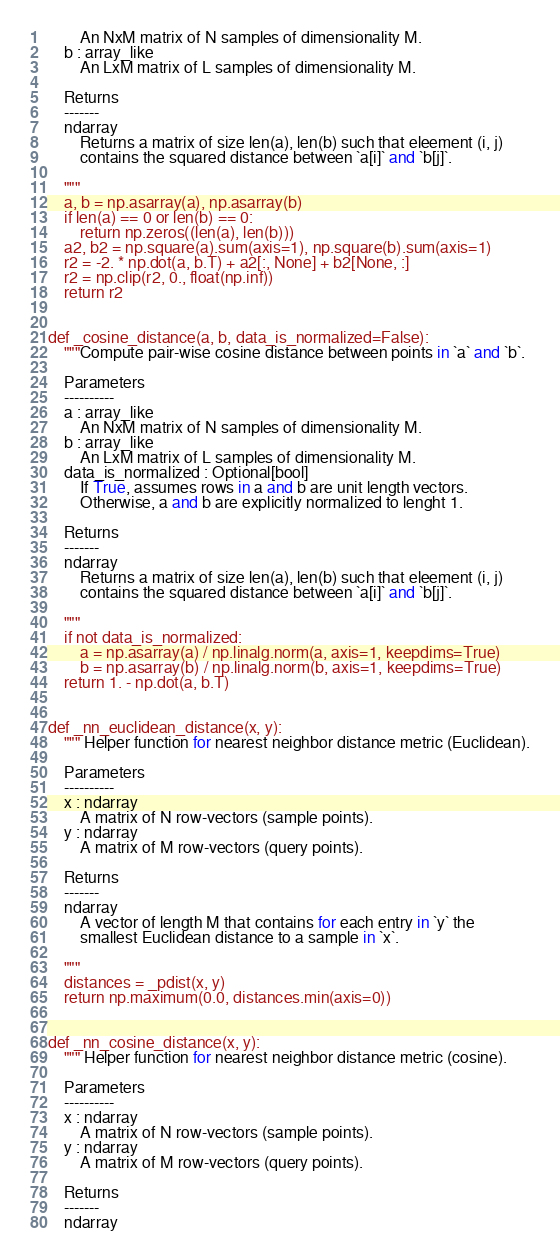<code> <loc_0><loc_0><loc_500><loc_500><_Python_>        An NxM matrix of N samples of dimensionality M.
    b : array_like
        An LxM matrix of L samples of dimensionality M.

    Returns
    -------
    ndarray
        Returns a matrix of size len(a), len(b) such that eleement (i, j)
        contains the squared distance between `a[i]` and `b[j]`.

    """
    a, b = np.asarray(a), np.asarray(b)
    if len(a) == 0 or len(b) == 0:
        return np.zeros((len(a), len(b)))
    a2, b2 = np.square(a).sum(axis=1), np.square(b).sum(axis=1)
    r2 = -2. * np.dot(a, b.T) + a2[:, None] + b2[None, :]
    r2 = np.clip(r2, 0., float(np.inf))
    return r2


def _cosine_distance(a, b, data_is_normalized=False):
    """Compute pair-wise cosine distance between points in `a` and `b`.

    Parameters
    ----------
    a : array_like
        An NxM matrix of N samples of dimensionality M.
    b : array_like
        An LxM matrix of L samples of dimensionality M.
    data_is_normalized : Optional[bool]
        If True, assumes rows in a and b are unit length vectors.
        Otherwise, a and b are explicitly normalized to lenght 1.

    Returns
    -------
    ndarray
        Returns a matrix of size len(a), len(b) such that eleement (i, j)
        contains the squared distance between `a[i]` and `b[j]`.

    """
    if not data_is_normalized:
        a = np.asarray(a) / np.linalg.norm(a, axis=1, keepdims=True)
        b = np.asarray(b) / np.linalg.norm(b, axis=1, keepdims=True)
    return 1. - np.dot(a, b.T)


def _nn_euclidean_distance(x, y):
    """ Helper function for nearest neighbor distance metric (Euclidean).

    Parameters
    ----------
    x : ndarray
        A matrix of N row-vectors (sample points).
    y : ndarray
        A matrix of M row-vectors (query points).

    Returns
    -------
    ndarray
        A vector of length M that contains for each entry in `y` the
        smallest Euclidean distance to a sample in `x`.

    """
    distances = _pdist(x, y)
    return np.maximum(0.0, distances.min(axis=0))


def _nn_cosine_distance(x, y):
    """ Helper function for nearest neighbor distance metric (cosine).

    Parameters
    ----------
    x : ndarray
        A matrix of N row-vectors (sample points).
    y : ndarray
        A matrix of M row-vectors (query points).

    Returns
    -------
    ndarray</code> 